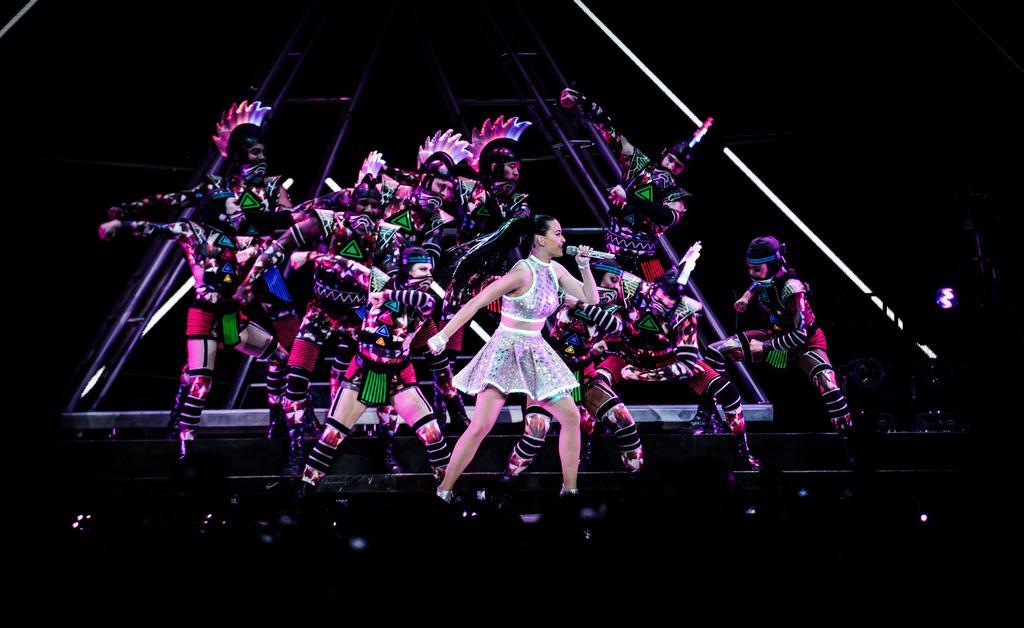Please provide a concise description of this image. In this given picture, I can see a group of people dancing and the women who is standing in front is holding a mike. 